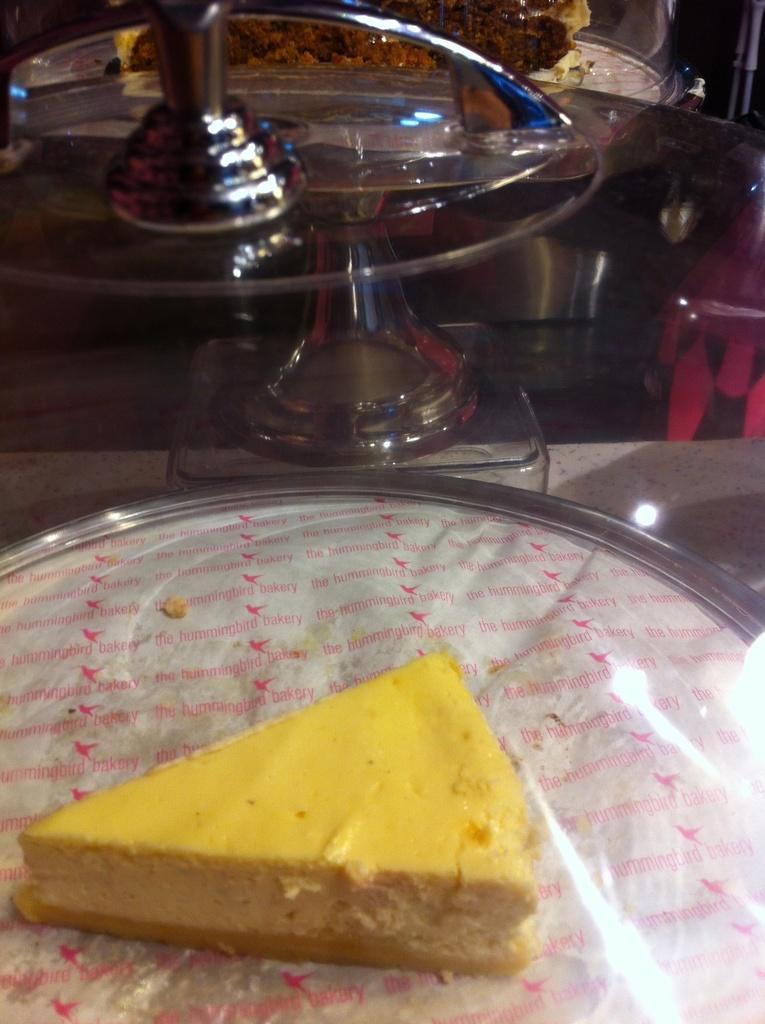Could you give a brief overview of what you see in this image? In this picture there is a yellow color piece of cake on steel plate. On the table we can see glass box and plate. On the right there is a chair near to the round table. 